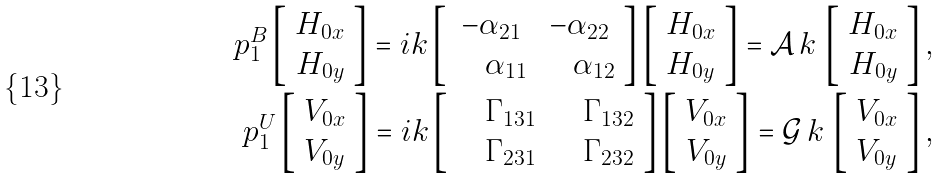Convert formula to latex. <formula><loc_0><loc_0><loc_500><loc_500>p ^ { B } _ { 1 } \left [ \begin{array} { c } H _ { 0 x } \\ H _ { 0 y } \end{array} \right ] = i k \left [ \begin{array} { c c } - \alpha _ { 2 1 } & - \alpha _ { 2 2 } \\ \quad \alpha _ { 1 1 } & \quad \alpha _ { 1 2 } \end{array} \right ] \left [ \begin{array} { c } H _ { 0 x } \\ H _ { 0 y } \end{array} \right ] = \mathcal { A } \, k \, \left [ \begin{array} { c } H _ { 0 x } \\ H _ { 0 y } \end{array} \right ] , \\ p ^ { U } _ { 1 } \left [ \begin{array} { c } V _ { 0 x } \\ V _ { 0 y } \end{array} \right ] = i k \left [ \begin{array} { c c } \quad \Gamma _ { 1 3 1 } & \quad \Gamma _ { 1 3 2 } \\ \quad \Gamma _ { 2 3 1 } & \quad \Gamma _ { 2 3 2 } \end{array} \right ] \left [ \begin{array} { c } V _ { 0 x } \\ V _ { 0 y } \end{array} \right ] = \mathcal { G } \, k \, \left [ \begin{array} { c } V _ { 0 x } \\ V _ { 0 y } \end{array} \right ] ,</formula> 